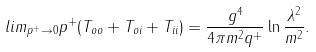Convert formula to latex. <formula><loc_0><loc_0><loc_500><loc_500>l i m _ { p ^ { + } \rightarrow 0 } p ^ { + } ( T _ { o o } + T _ { o i } + T _ { i i } ) = \frac { g ^ { 4 } } { 4 \pi m ^ { 2 } q ^ { + } } \ln \frac { \lambda ^ { 2 } } { m ^ { 2 } } .</formula> 